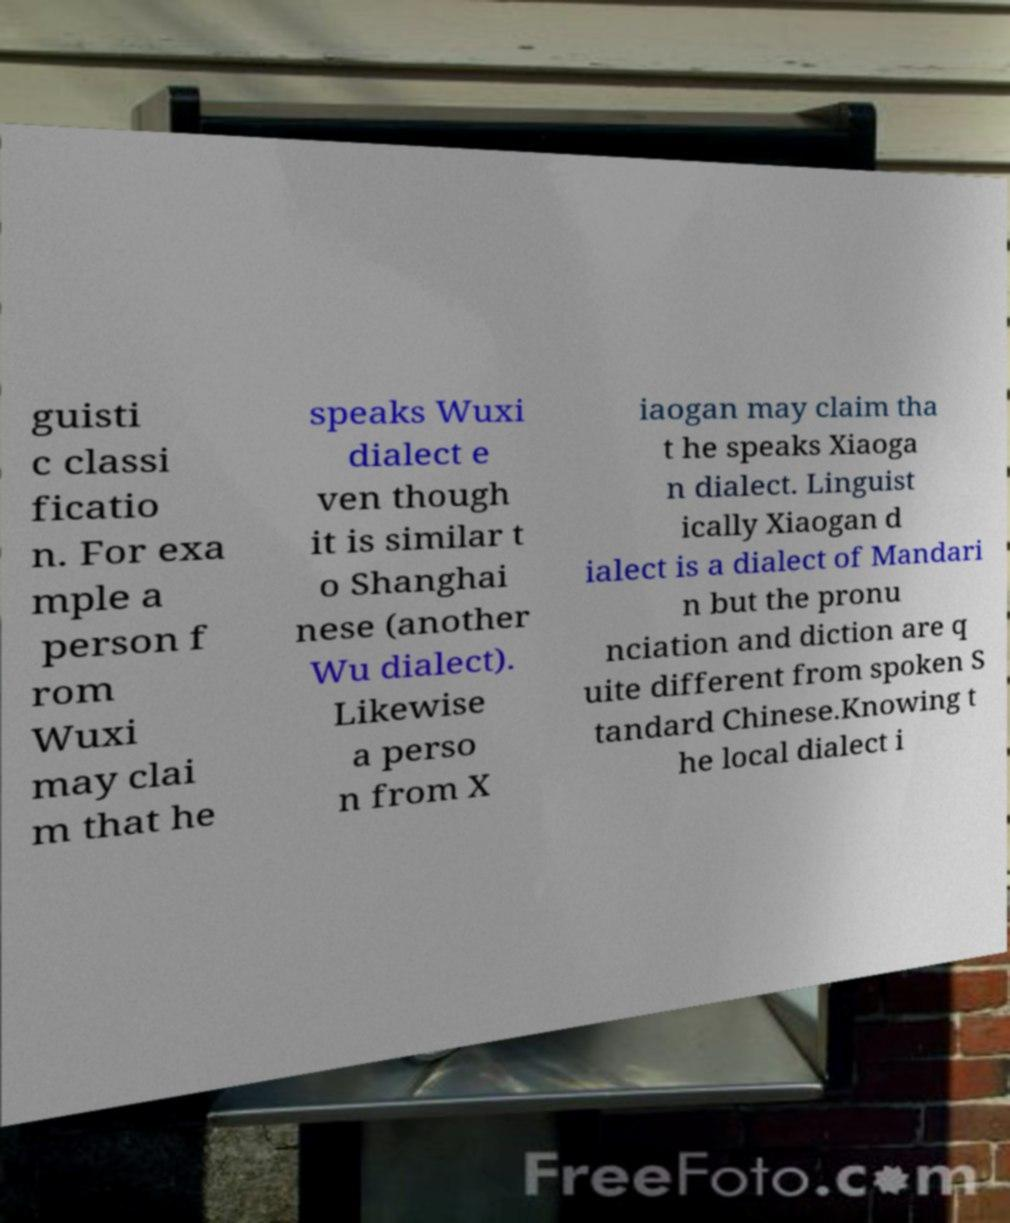Can you accurately transcribe the text from the provided image for me? guisti c classi ficatio n. For exa mple a person f rom Wuxi may clai m that he speaks Wuxi dialect e ven though it is similar t o Shanghai nese (another Wu dialect). Likewise a perso n from X iaogan may claim tha t he speaks Xiaoga n dialect. Linguist ically Xiaogan d ialect is a dialect of Mandari n but the pronu nciation and diction are q uite different from spoken S tandard Chinese.Knowing t he local dialect i 